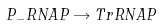<formula> <loc_0><loc_0><loc_500><loc_500>P _ { - } R N A P \rightarrow T r R N A P</formula> 